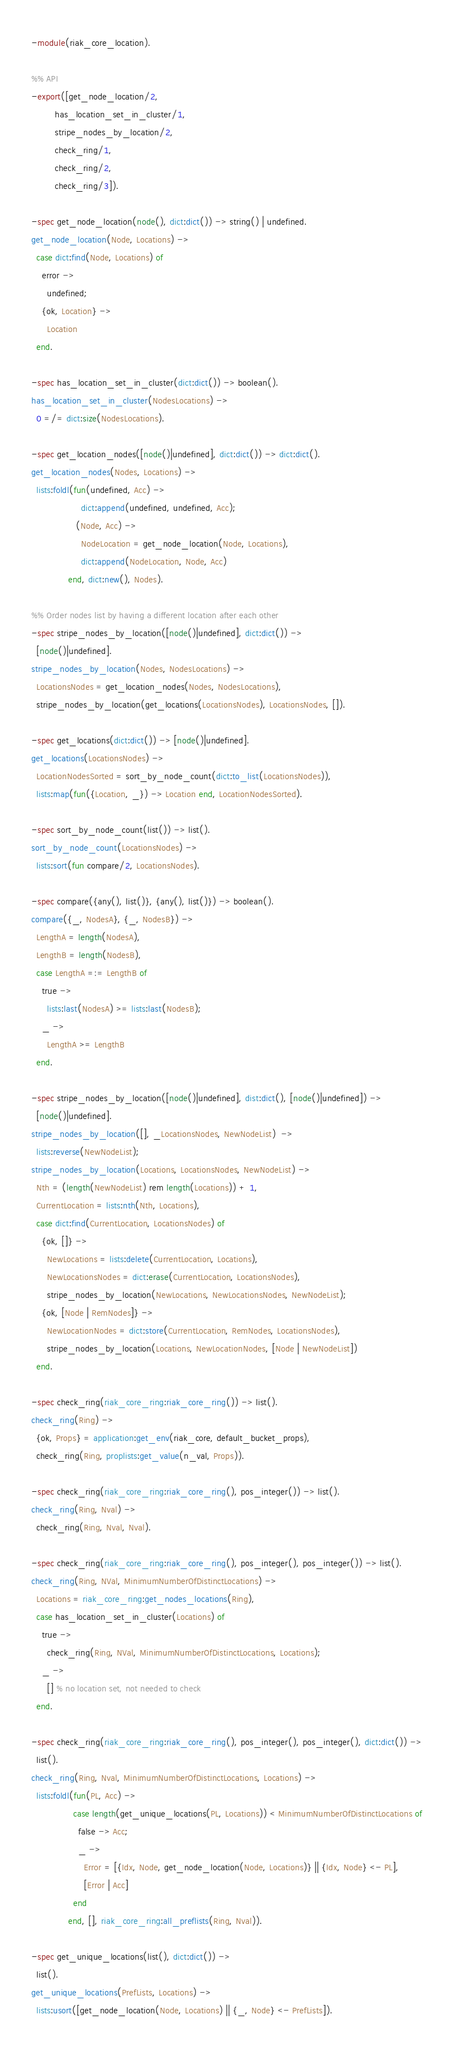Convert code to text. <code><loc_0><loc_0><loc_500><loc_500><_Erlang_>-module(riak_core_location).

%% API
-export([get_node_location/2,
         has_location_set_in_cluster/1,
         stripe_nodes_by_location/2,
         check_ring/1,
         check_ring/2,
         check_ring/3]).

-spec get_node_location(node(), dict:dict()) -> string() | undefined.
get_node_location(Node, Locations) ->
  case dict:find(Node, Locations) of
    error ->
      undefined;
    {ok, Location} ->
      Location
  end.

-spec has_location_set_in_cluster(dict:dict()) -> boolean().
has_location_set_in_cluster(NodesLocations) ->
  0 =/= dict:size(NodesLocations).

-spec get_location_nodes([node()|undefined], dict:dict()) -> dict:dict().
get_location_nodes(Nodes, Locations) ->
  lists:foldl(fun(undefined, Acc) ->
                   dict:append(undefined, undefined, Acc);
                 (Node, Acc) ->
                   NodeLocation = get_node_location(Node, Locations),
                   dict:append(NodeLocation, Node, Acc)
              end, dict:new(), Nodes).

%% Order nodes list by having a different location after each other
-spec stripe_nodes_by_location([node()|undefined], dict:dict()) ->
  [node()|undefined].
stripe_nodes_by_location(Nodes, NodesLocations) ->
  LocationsNodes = get_location_nodes(Nodes, NodesLocations),
  stripe_nodes_by_location(get_locations(LocationsNodes), LocationsNodes, []).

-spec get_locations(dict:dict()) -> [node()|undefined].
get_locations(LocationsNodes) ->
  LocationNodesSorted = sort_by_node_count(dict:to_list(LocationsNodes)),
  lists:map(fun({Location, _}) -> Location end, LocationNodesSorted).

-spec sort_by_node_count(list()) -> list().
sort_by_node_count(LocationsNodes) ->
  lists:sort(fun compare/2, LocationsNodes).

-spec compare({any(), list()}, {any(), list()}) -> boolean().
compare({_, NodesA}, {_, NodesB}) ->
  LengthA = length(NodesA),
  LengthB = length(NodesB),
  case LengthA =:= LengthB of
    true ->
      lists:last(NodesA) >= lists:last(NodesB);
    _ ->
      LengthA >= LengthB
  end.

-spec stripe_nodes_by_location([node()|undefined], dist:dict(), [node()|undefined]) ->
  [node()|undefined].
stripe_nodes_by_location([], _LocationsNodes, NewNodeList)  ->
  lists:reverse(NewNodeList);
stripe_nodes_by_location(Locations, LocationsNodes, NewNodeList) ->
  Nth = (length(NewNodeList) rem length(Locations)) + 1,
  CurrentLocation = lists:nth(Nth, Locations),
  case dict:find(CurrentLocation, LocationsNodes) of
    {ok, []} ->
      NewLocations = lists:delete(CurrentLocation, Locations),
      NewLocationsNodes = dict:erase(CurrentLocation, LocationsNodes),
      stripe_nodes_by_location(NewLocations, NewLocationsNodes, NewNodeList);
    {ok, [Node | RemNodes]} ->
      NewLocationNodes = dict:store(CurrentLocation, RemNodes, LocationsNodes),
      stripe_nodes_by_location(Locations, NewLocationNodes, [Node | NewNodeList])
  end.

-spec check_ring(riak_core_ring:riak_core_ring()) -> list().
check_ring(Ring) ->
  {ok, Props} = application:get_env(riak_core, default_bucket_props),
  check_ring(Ring, proplists:get_value(n_val, Props)).

-spec check_ring(riak_core_ring:riak_core_ring(), pos_integer()) -> list().
check_ring(Ring, Nval) ->
  check_ring(Ring, Nval, Nval).

-spec check_ring(riak_core_ring:riak_core_ring(), pos_integer(), pos_integer()) -> list().
check_ring(Ring, NVal, MinimumNumberOfDistinctLocations) ->
  Locations = riak_core_ring:get_nodes_locations(Ring),
  case has_location_set_in_cluster(Locations) of
    true ->
      check_ring(Ring, NVal, MinimumNumberOfDistinctLocations, Locations);
    _ ->
      [] % no location set, not needed to check
  end.

-spec check_ring(riak_core_ring:riak_core_ring(), pos_integer(), pos_integer(), dict:dict()) ->
  list().
check_ring(Ring, Nval, MinimumNumberOfDistinctLocations, Locations) ->
  lists:foldl(fun(PL, Acc) ->
                case length(get_unique_locations(PL, Locations)) < MinimumNumberOfDistinctLocations of
                  false -> Acc;
                  _ ->
                    Error = [{Idx, Node, get_node_location(Node, Locations)} || {Idx, Node} <- PL],
                    [Error | Acc]
                end
              end, [], riak_core_ring:all_preflists(Ring, Nval)).

-spec get_unique_locations(list(), dict:dict()) ->
  list().
get_unique_locations(PrefLists, Locations) ->
  lists:usort([get_node_location(Node, Locations) || {_, Node} <- PrefLists]).</code> 